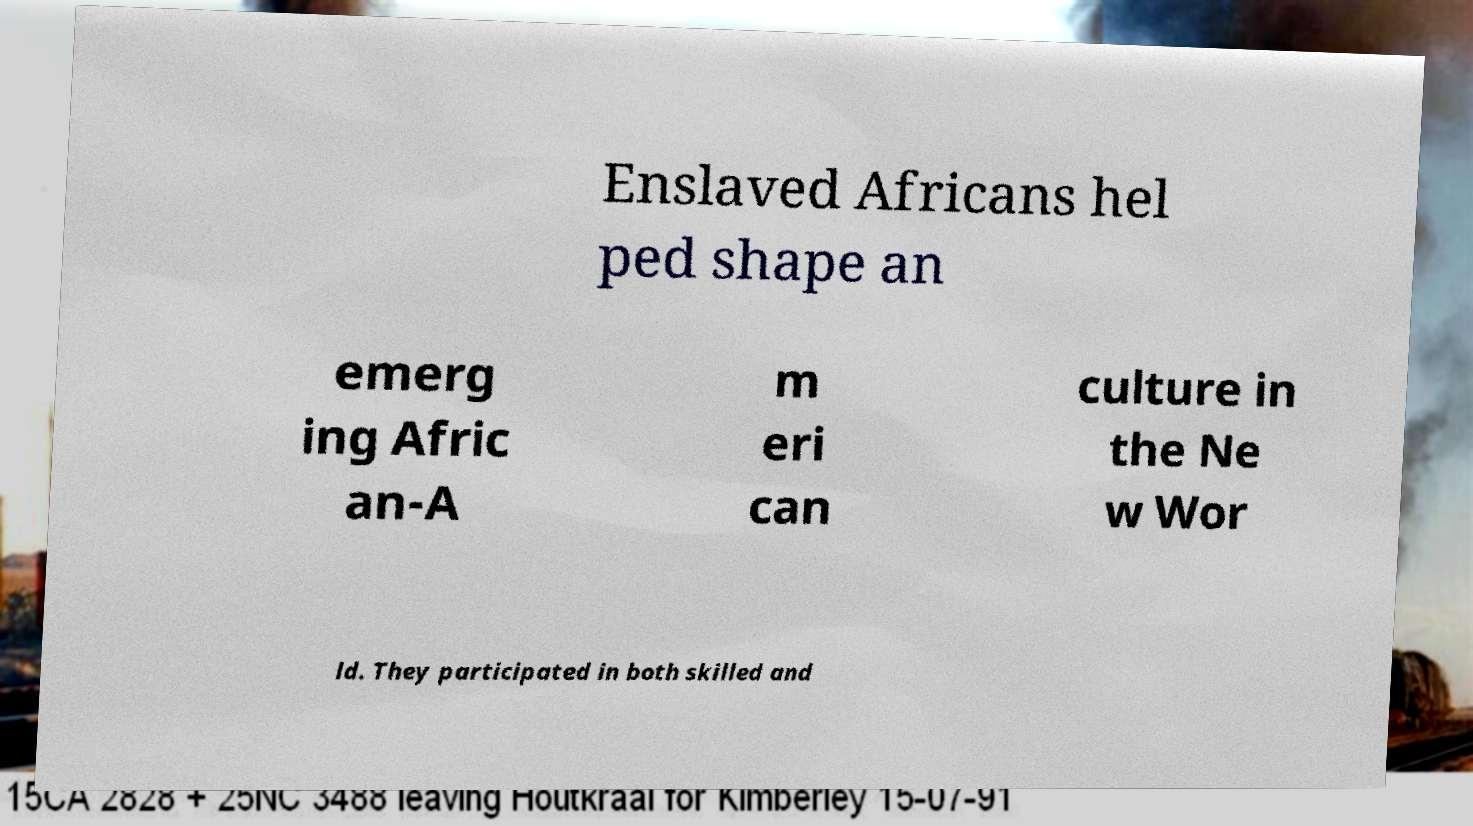Could you extract and type out the text from this image? Enslaved Africans hel ped shape an emerg ing Afric an-A m eri can culture in the Ne w Wor ld. They participated in both skilled and 